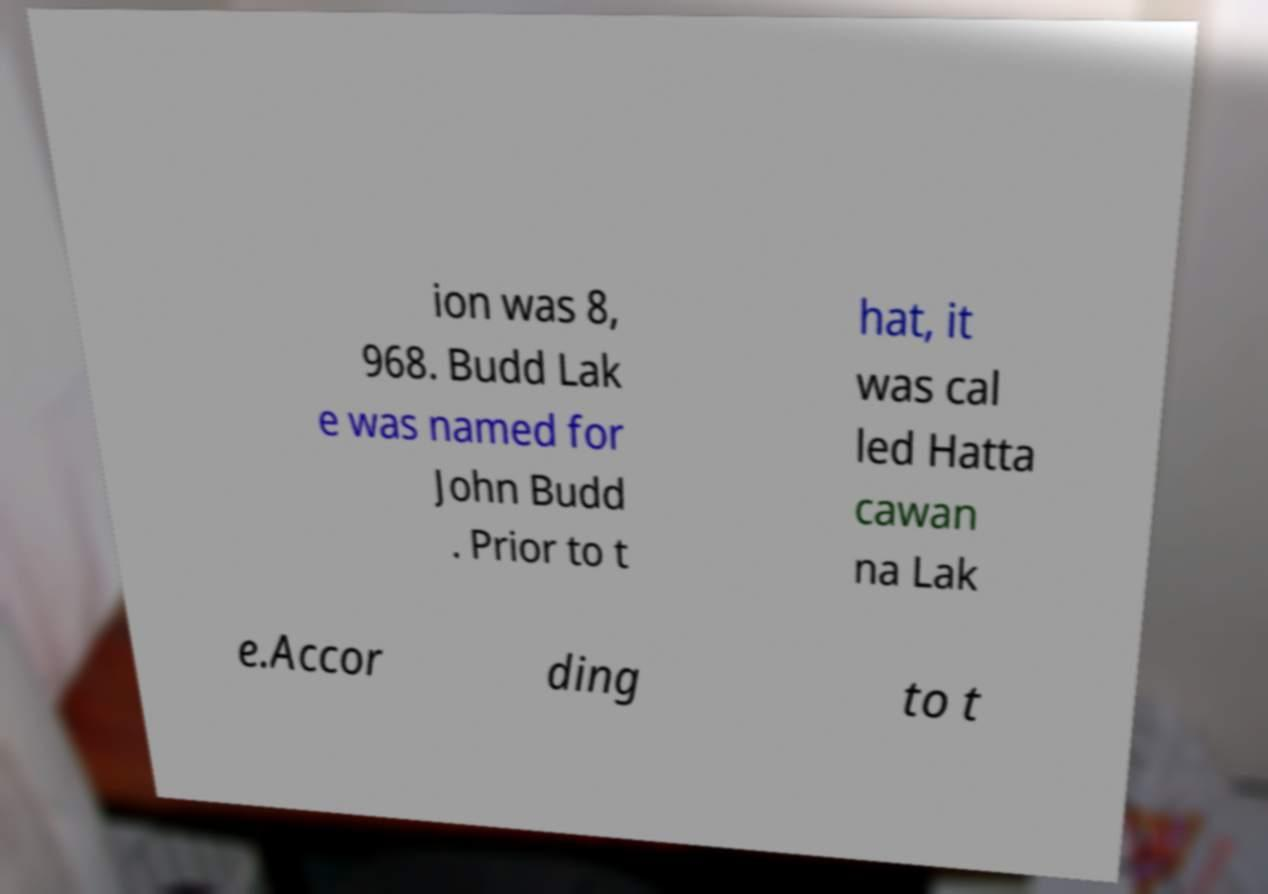Could you extract and type out the text from this image? ion was 8, 968. Budd Lak e was named for John Budd . Prior to t hat, it was cal led Hatta cawan na Lak e.Accor ding to t 